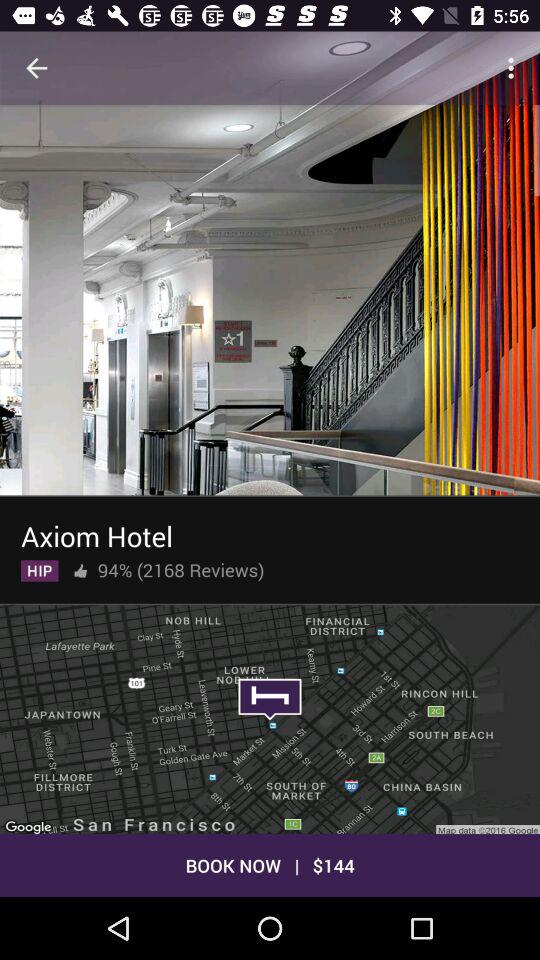How many reviews does the Axiom Hotel have?
Answer the question using a single word or phrase. 2168 